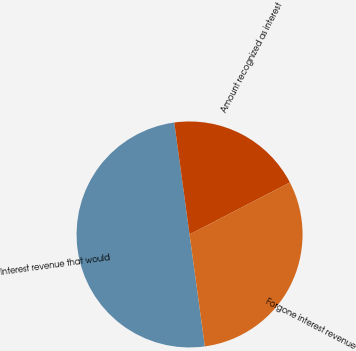Convert chart to OTSL. <chart><loc_0><loc_0><loc_500><loc_500><pie_chart><fcel>Interest revenue that would<fcel>Amount recognized as interest<fcel>Forgone interest revenue<nl><fcel>50.0%<fcel>19.55%<fcel>30.45%<nl></chart> 